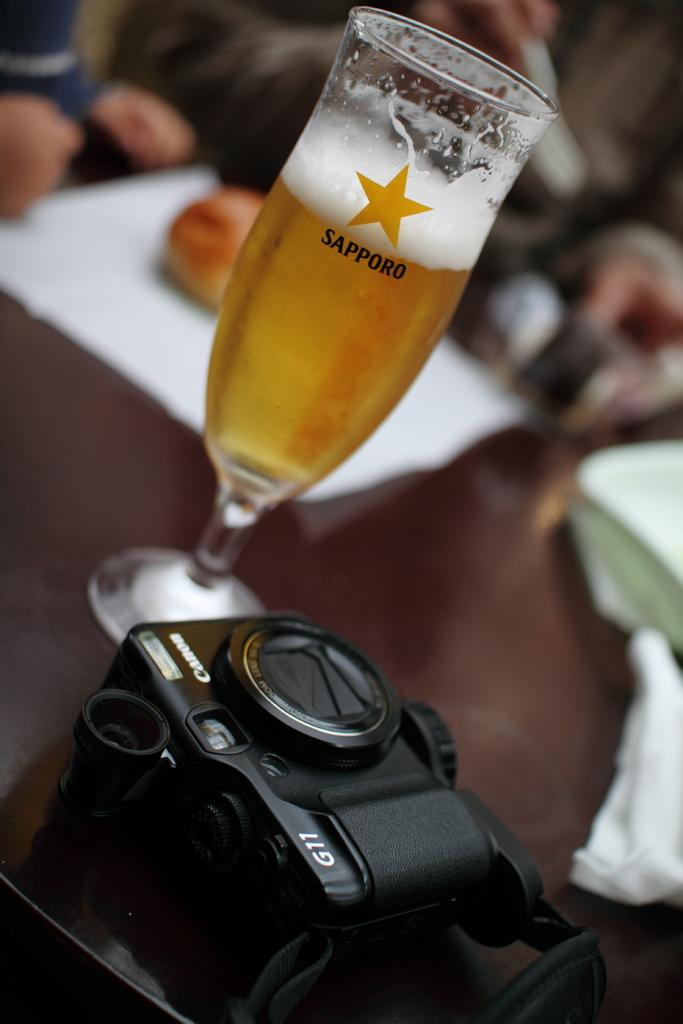What is the main object in the image? There is a camera in the image. What else can be seen on the table in the image? There is a wine glass, a paper, plates, and other objects on the table. How many persons are in the image? There are two persons in the image. What are the two persons doing in the image? The two persons are sitting on chairs. Can you tell me how many times the person on the left is blinking their eyes in the image? There is no information about the person's eye movements in the image, so it cannot be determined. 